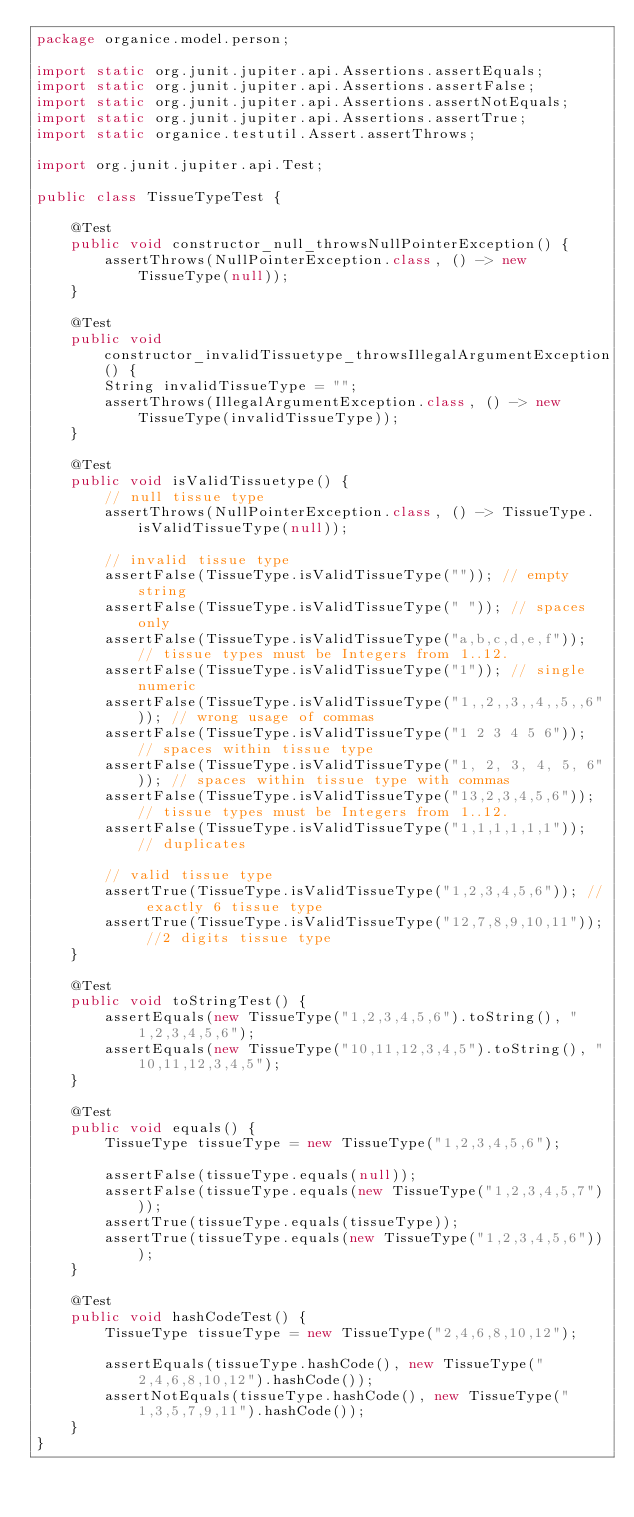<code> <loc_0><loc_0><loc_500><loc_500><_Java_>package organice.model.person;

import static org.junit.jupiter.api.Assertions.assertEquals;
import static org.junit.jupiter.api.Assertions.assertFalse;
import static org.junit.jupiter.api.Assertions.assertNotEquals;
import static org.junit.jupiter.api.Assertions.assertTrue;
import static organice.testutil.Assert.assertThrows;

import org.junit.jupiter.api.Test;

public class TissueTypeTest {

    @Test
    public void constructor_null_throwsNullPointerException() {
        assertThrows(NullPointerException.class, () -> new TissueType(null));
    }

    @Test
    public void constructor_invalidTissuetype_throwsIllegalArgumentException() {
        String invalidTissueType = "";
        assertThrows(IllegalArgumentException.class, () -> new TissueType(invalidTissueType));
    }

    @Test
    public void isValidTissuetype() {
        // null tissue type
        assertThrows(NullPointerException.class, () -> TissueType.isValidTissueType(null));

        // invalid tissue type
        assertFalse(TissueType.isValidTissueType("")); // empty string
        assertFalse(TissueType.isValidTissueType(" ")); // spaces only
        assertFalse(TissueType.isValidTissueType("a,b,c,d,e,f")); // tissue types must be Integers from 1..12.
        assertFalse(TissueType.isValidTissueType("1")); // single numeric
        assertFalse(TissueType.isValidTissueType("1,,2,,3,,4,,5,,6")); // wrong usage of commas
        assertFalse(TissueType.isValidTissueType("1 2 3 4 5 6")); // spaces within tissue type
        assertFalse(TissueType.isValidTissueType("1, 2, 3, 4, 5, 6")); // spaces within tissue type with commas
        assertFalse(TissueType.isValidTissueType("13,2,3,4,5,6")); // tissue types must be Integers from 1..12.
        assertFalse(TissueType.isValidTissueType("1,1,1,1,1,1")); // duplicates

        // valid tissue type
        assertTrue(TissueType.isValidTissueType("1,2,3,4,5,6")); // exactly 6 tissue type
        assertTrue(TissueType.isValidTissueType("12,7,8,9,10,11")); //2 digits tissue type
    }

    @Test
    public void toStringTest() {
        assertEquals(new TissueType("1,2,3,4,5,6").toString(), "1,2,3,4,5,6");
        assertEquals(new TissueType("10,11,12,3,4,5").toString(), "10,11,12,3,4,5");
    }

    @Test
    public void equals() {
        TissueType tissueType = new TissueType("1,2,3,4,5,6");

        assertFalse(tissueType.equals(null));
        assertFalse(tissueType.equals(new TissueType("1,2,3,4,5,7")));
        assertTrue(tissueType.equals(tissueType));
        assertTrue(tissueType.equals(new TissueType("1,2,3,4,5,6")));
    }

    @Test
    public void hashCodeTest() {
        TissueType tissueType = new TissueType("2,4,6,8,10,12");

        assertEquals(tissueType.hashCode(), new TissueType("2,4,6,8,10,12").hashCode());
        assertNotEquals(tissueType.hashCode(), new TissueType("1,3,5,7,9,11").hashCode());
    }
}
</code> 